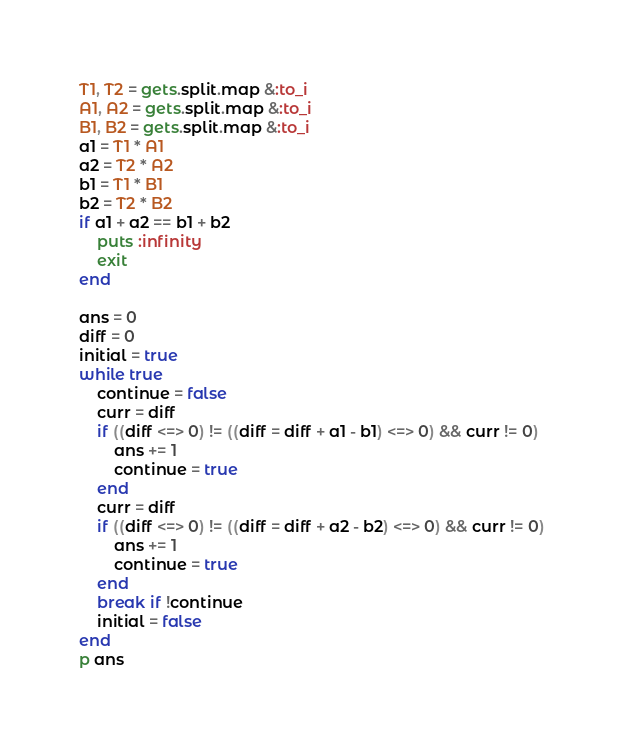<code> <loc_0><loc_0><loc_500><loc_500><_Ruby_>T1, T2 = gets.split.map &:to_i
A1, A2 = gets.split.map &:to_i
B1, B2 = gets.split.map &:to_i
a1 = T1 * A1
a2 = T2 * A2
b1 = T1 * B1
b2 = T2 * B2
if a1 + a2 == b1 + b2
    puts :infinity
    exit
end

ans = 0
diff = 0
initial = true
while true
    continue = false
    curr = diff
    if ((diff <=> 0) != ((diff = diff + a1 - b1) <=> 0) && curr != 0)
        ans += 1
        continue = true
    end
    curr = diff
    if ((diff <=> 0) != ((diff = diff + a2 - b2) <=> 0) && curr != 0)
        ans += 1
        continue = true
    end
    break if !continue
    initial = false
end
p ans</code> 